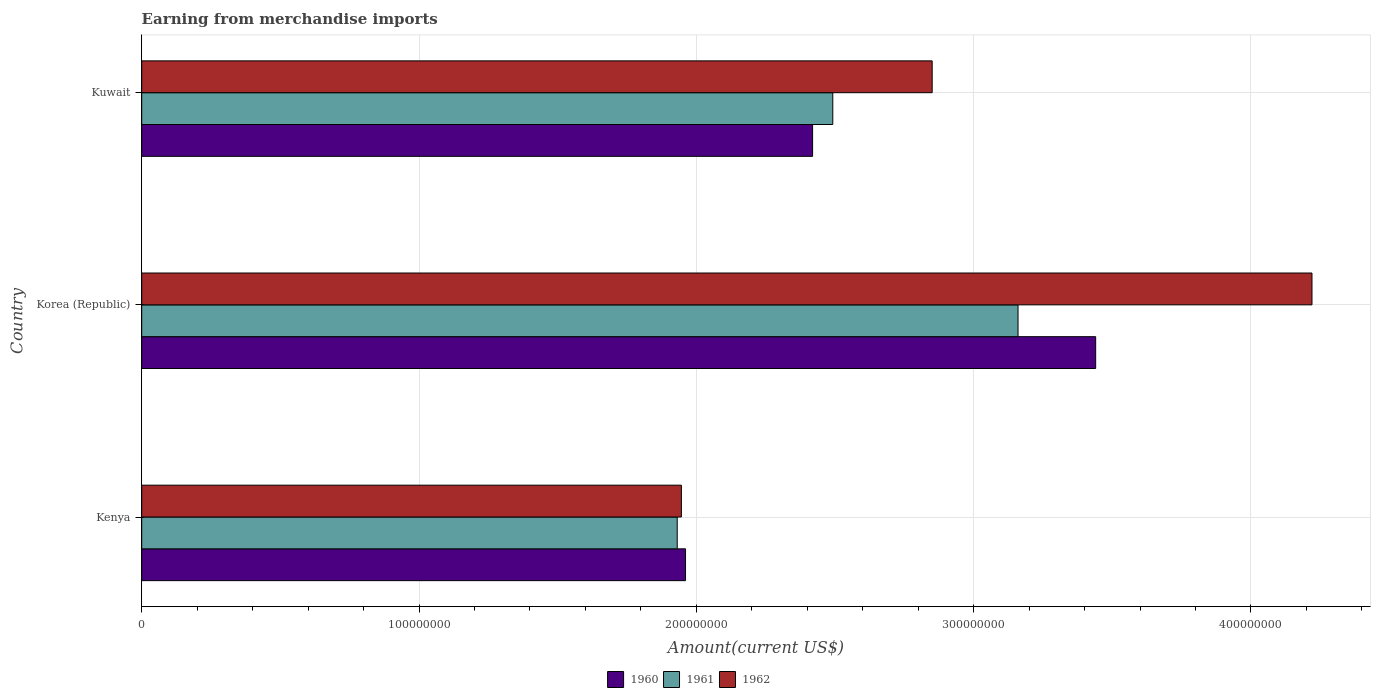Are the number of bars per tick equal to the number of legend labels?
Your answer should be compact. Yes. How many bars are there on the 3rd tick from the bottom?
Offer a very short reply. 3. What is the label of the 3rd group of bars from the top?
Your response must be concise. Kenya. In how many cases, is the number of bars for a given country not equal to the number of legend labels?
Your answer should be very brief. 0. What is the amount earned from merchandise imports in 1960 in Kenya?
Your answer should be compact. 1.96e+08. Across all countries, what is the maximum amount earned from merchandise imports in 1961?
Provide a short and direct response. 3.16e+08. Across all countries, what is the minimum amount earned from merchandise imports in 1960?
Give a very brief answer. 1.96e+08. In which country was the amount earned from merchandise imports in 1960 minimum?
Provide a succinct answer. Kenya. What is the total amount earned from merchandise imports in 1962 in the graph?
Provide a succinct answer. 9.02e+08. What is the difference between the amount earned from merchandise imports in 1962 in Korea (Republic) and that in Kuwait?
Offer a terse response. 1.37e+08. What is the difference between the amount earned from merchandise imports in 1960 in Kenya and the amount earned from merchandise imports in 1961 in Korea (Republic)?
Provide a short and direct response. -1.20e+08. What is the average amount earned from merchandise imports in 1961 per country?
Provide a succinct answer. 2.53e+08. What is the difference between the amount earned from merchandise imports in 1961 and amount earned from merchandise imports in 1960 in Korea (Republic)?
Your answer should be very brief. -2.80e+07. What is the ratio of the amount earned from merchandise imports in 1960 in Korea (Republic) to that in Kuwait?
Offer a very short reply. 1.42. Is the amount earned from merchandise imports in 1960 in Kenya less than that in Kuwait?
Offer a very short reply. Yes. Is the difference between the amount earned from merchandise imports in 1961 in Korea (Republic) and Kuwait greater than the difference between the amount earned from merchandise imports in 1960 in Korea (Republic) and Kuwait?
Provide a short and direct response. No. What is the difference between the highest and the second highest amount earned from merchandise imports in 1960?
Give a very brief answer. 1.02e+08. What is the difference between the highest and the lowest amount earned from merchandise imports in 1962?
Your answer should be very brief. 2.27e+08. In how many countries, is the amount earned from merchandise imports in 1960 greater than the average amount earned from merchandise imports in 1960 taken over all countries?
Your answer should be compact. 1. How many bars are there?
Offer a terse response. 9. What is the difference between two consecutive major ticks on the X-axis?
Keep it short and to the point. 1.00e+08. How many legend labels are there?
Ensure brevity in your answer.  3. What is the title of the graph?
Your answer should be compact. Earning from merchandise imports. Does "2011" appear as one of the legend labels in the graph?
Offer a terse response. No. What is the label or title of the X-axis?
Offer a very short reply. Amount(current US$). What is the label or title of the Y-axis?
Give a very brief answer. Country. What is the Amount(current US$) of 1960 in Kenya?
Your answer should be very brief. 1.96e+08. What is the Amount(current US$) in 1961 in Kenya?
Provide a succinct answer. 1.93e+08. What is the Amount(current US$) in 1962 in Kenya?
Your response must be concise. 1.95e+08. What is the Amount(current US$) of 1960 in Korea (Republic)?
Offer a very short reply. 3.44e+08. What is the Amount(current US$) of 1961 in Korea (Republic)?
Make the answer very short. 3.16e+08. What is the Amount(current US$) of 1962 in Korea (Republic)?
Make the answer very short. 4.22e+08. What is the Amount(current US$) in 1960 in Kuwait?
Give a very brief answer. 2.42e+08. What is the Amount(current US$) of 1961 in Kuwait?
Provide a short and direct response. 2.49e+08. What is the Amount(current US$) of 1962 in Kuwait?
Your response must be concise. 2.85e+08. Across all countries, what is the maximum Amount(current US$) of 1960?
Make the answer very short. 3.44e+08. Across all countries, what is the maximum Amount(current US$) in 1961?
Offer a terse response. 3.16e+08. Across all countries, what is the maximum Amount(current US$) in 1962?
Your answer should be compact. 4.22e+08. Across all countries, what is the minimum Amount(current US$) in 1960?
Offer a very short reply. 1.96e+08. Across all countries, what is the minimum Amount(current US$) in 1961?
Your answer should be very brief. 1.93e+08. Across all countries, what is the minimum Amount(current US$) of 1962?
Keep it short and to the point. 1.95e+08. What is the total Amount(current US$) in 1960 in the graph?
Provide a succinct answer. 7.82e+08. What is the total Amount(current US$) of 1961 in the graph?
Offer a very short reply. 7.58e+08. What is the total Amount(current US$) in 1962 in the graph?
Keep it short and to the point. 9.02e+08. What is the difference between the Amount(current US$) in 1960 in Kenya and that in Korea (Republic)?
Provide a succinct answer. -1.48e+08. What is the difference between the Amount(current US$) of 1961 in Kenya and that in Korea (Republic)?
Keep it short and to the point. -1.23e+08. What is the difference between the Amount(current US$) in 1962 in Kenya and that in Korea (Republic)?
Offer a very short reply. -2.27e+08. What is the difference between the Amount(current US$) of 1960 in Kenya and that in Kuwait?
Provide a succinct answer. -4.58e+07. What is the difference between the Amount(current US$) of 1961 in Kenya and that in Kuwait?
Your answer should be compact. -5.61e+07. What is the difference between the Amount(current US$) in 1962 in Kenya and that in Kuwait?
Give a very brief answer. -9.04e+07. What is the difference between the Amount(current US$) in 1960 in Korea (Republic) and that in Kuwait?
Offer a terse response. 1.02e+08. What is the difference between the Amount(current US$) in 1961 in Korea (Republic) and that in Kuwait?
Give a very brief answer. 6.68e+07. What is the difference between the Amount(current US$) of 1962 in Korea (Republic) and that in Kuwait?
Keep it short and to the point. 1.37e+08. What is the difference between the Amount(current US$) in 1960 in Kenya and the Amount(current US$) in 1961 in Korea (Republic)?
Your answer should be compact. -1.20e+08. What is the difference between the Amount(current US$) of 1960 in Kenya and the Amount(current US$) of 1962 in Korea (Republic)?
Provide a short and direct response. -2.26e+08. What is the difference between the Amount(current US$) of 1961 in Kenya and the Amount(current US$) of 1962 in Korea (Republic)?
Offer a very short reply. -2.29e+08. What is the difference between the Amount(current US$) in 1960 in Kenya and the Amount(current US$) in 1961 in Kuwait?
Ensure brevity in your answer.  -5.31e+07. What is the difference between the Amount(current US$) of 1960 in Kenya and the Amount(current US$) of 1962 in Kuwait?
Make the answer very short. -8.89e+07. What is the difference between the Amount(current US$) in 1961 in Kenya and the Amount(current US$) in 1962 in Kuwait?
Give a very brief answer. -9.19e+07. What is the difference between the Amount(current US$) of 1960 in Korea (Republic) and the Amount(current US$) of 1961 in Kuwait?
Give a very brief answer. 9.48e+07. What is the difference between the Amount(current US$) of 1960 in Korea (Republic) and the Amount(current US$) of 1962 in Kuwait?
Make the answer very short. 5.90e+07. What is the difference between the Amount(current US$) of 1961 in Korea (Republic) and the Amount(current US$) of 1962 in Kuwait?
Give a very brief answer. 3.10e+07. What is the average Amount(current US$) in 1960 per country?
Provide a short and direct response. 2.61e+08. What is the average Amount(current US$) in 1961 per country?
Your answer should be very brief. 2.53e+08. What is the average Amount(current US$) of 1962 per country?
Provide a short and direct response. 3.01e+08. What is the difference between the Amount(current US$) in 1960 and Amount(current US$) in 1961 in Kenya?
Your response must be concise. 3.00e+06. What is the difference between the Amount(current US$) in 1960 and Amount(current US$) in 1962 in Kenya?
Provide a short and direct response. 1.50e+06. What is the difference between the Amount(current US$) of 1961 and Amount(current US$) of 1962 in Kenya?
Keep it short and to the point. -1.50e+06. What is the difference between the Amount(current US$) in 1960 and Amount(current US$) in 1961 in Korea (Republic)?
Offer a very short reply. 2.80e+07. What is the difference between the Amount(current US$) of 1960 and Amount(current US$) of 1962 in Korea (Republic)?
Keep it short and to the point. -7.80e+07. What is the difference between the Amount(current US$) of 1961 and Amount(current US$) of 1962 in Korea (Republic)?
Your answer should be compact. -1.06e+08. What is the difference between the Amount(current US$) in 1960 and Amount(current US$) in 1961 in Kuwait?
Provide a succinct answer. -7.28e+06. What is the difference between the Amount(current US$) of 1960 and Amount(current US$) of 1962 in Kuwait?
Make the answer very short. -4.31e+07. What is the difference between the Amount(current US$) of 1961 and Amount(current US$) of 1962 in Kuwait?
Offer a terse response. -3.58e+07. What is the ratio of the Amount(current US$) of 1960 in Kenya to that in Korea (Republic)?
Offer a very short reply. 0.57. What is the ratio of the Amount(current US$) of 1961 in Kenya to that in Korea (Republic)?
Make the answer very short. 0.61. What is the ratio of the Amount(current US$) of 1962 in Kenya to that in Korea (Republic)?
Make the answer very short. 0.46. What is the ratio of the Amount(current US$) in 1960 in Kenya to that in Kuwait?
Your answer should be compact. 0.81. What is the ratio of the Amount(current US$) of 1961 in Kenya to that in Kuwait?
Give a very brief answer. 0.77. What is the ratio of the Amount(current US$) of 1962 in Kenya to that in Kuwait?
Ensure brevity in your answer.  0.68. What is the ratio of the Amount(current US$) of 1960 in Korea (Republic) to that in Kuwait?
Keep it short and to the point. 1.42. What is the ratio of the Amount(current US$) in 1961 in Korea (Republic) to that in Kuwait?
Provide a succinct answer. 1.27. What is the ratio of the Amount(current US$) in 1962 in Korea (Republic) to that in Kuwait?
Provide a short and direct response. 1.48. What is the difference between the highest and the second highest Amount(current US$) in 1960?
Your answer should be compact. 1.02e+08. What is the difference between the highest and the second highest Amount(current US$) in 1961?
Your answer should be very brief. 6.68e+07. What is the difference between the highest and the second highest Amount(current US$) of 1962?
Provide a short and direct response. 1.37e+08. What is the difference between the highest and the lowest Amount(current US$) in 1960?
Your answer should be compact. 1.48e+08. What is the difference between the highest and the lowest Amount(current US$) of 1961?
Your answer should be very brief. 1.23e+08. What is the difference between the highest and the lowest Amount(current US$) of 1962?
Give a very brief answer. 2.27e+08. 